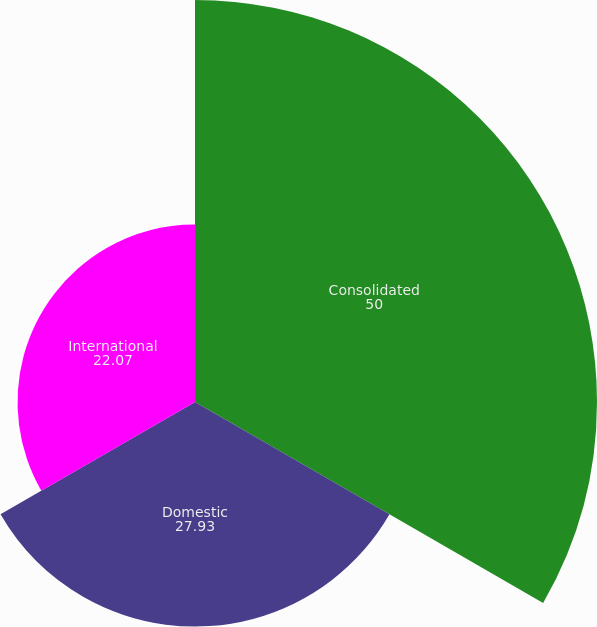<chart> <loc_0><loc_0><loc_500><loc_500><pie_chart><fcel>Consolidated<fcel>Domestic<fcel>International<nl><fcel>50.0%<fcel>27.93%<fcel>22.07%<nl></chart> 